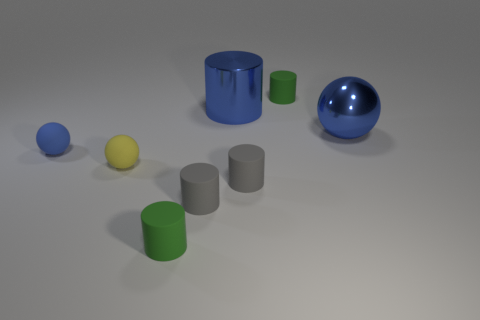Is the tiny blue object the same shape as the small yellow matte object?
Give a very brief answer. Yes. There is another blue thing that is the same shape as the tiny blue matte object; what size is it?
Your answer should be compact. Large. What number of things have the same color as the large shiny cylinder?
Ensure brevity in your answer.  2. How many things are green cylinders behind the yellow sphere or small blue matte objects?
Provide a short and direct response. 2. There is another sphere that is made of the same material as the small blue sphere; what is its color?
Give a very brief answer. Yellow. Is there a blue metallic object that has the same size as the yellow object?
Make the answer very short. No. What number of objects are big shiny objects behind the small yellow matte thing or small spheres that are left of the yellow matte sphere?
Give a very brief answer. 3. The blue object that is the same size as the yellow matte sphere is what shape?
Ensure brevity in your answer.  Sphere. Are there any big yellow things that have the same shape as the tiny blue thing?
Give a very brief answer. No. Are there fewer small yellow objects than green rubber things?
Provide a short and direct response. Yes. 